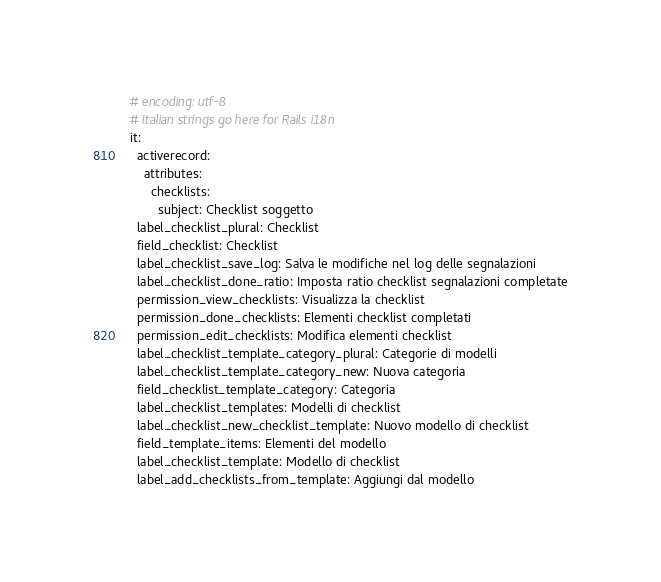<code> <loc_0><loc_0><loc_500><loc_500><_YAML_># encoding: utf-8
# Italian strings go here for Rails i18n
it:
  activerecord:
    attributes:
      checklists:
        subject: Checklist soggetto
  label_checklist_plural: Checklist
  field_checklist: Checklist
  label_checklist_save_log: Salva le modifiche nel log delle segnalazioni
  label_checklist_done_ratio: Imposta ratio checklist segnalazioni completate
  permission_view_checklists: Visualizza la checklist
  permission_done_checklists: Elementi checklist completati
  permission_edit_checklists: Modifica elementi checklist
  label_checklist_template_category_plural: Categorie di modelli
  label_checklist_template_category_new: Nuova categoria
  field_checklist_template_category: Categoria
  label_checklist_templates: Modelli di checklist
  label_checklist_new_checklist_template: Nuovo modello di checklist
  field_template_items: Elementi del modello
  label_checklist_template: Modello di checklist
  label_add_checklists_from_template: Aggiungi dal modello</code> 